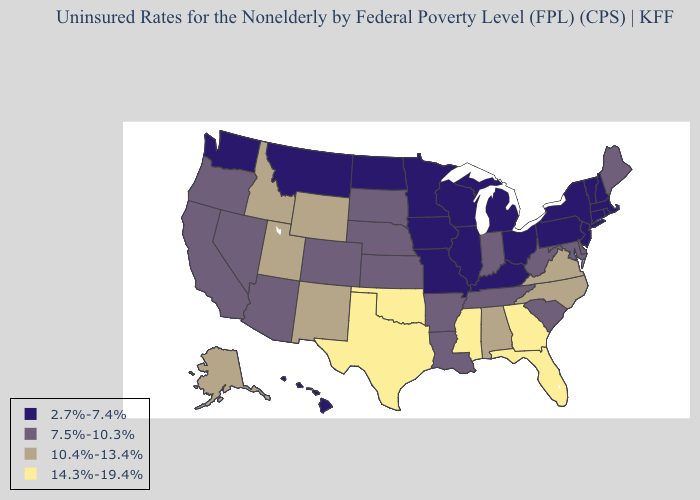Name the states that have a value in the range 10.4%-13.4%?
Keep it brief. Alabama, Alaska, Idaho, New Mexico, North Carolina, Utah, Virginia, Wyoming. What is the highest value in the West ?
Short answer required. 10.4%-13.4%. Which states have the lowest value in the USA?
Give a very brief answer. Connecticut, Hawaii, Illinois, Iowa, Kentucky, Massachusetts, Michigan, Minnesota, Missouri, Montana, New Hampshire, New Jersey, New York, North Dakota, Ohio, Pennsylvania, Rhode Island, Vermont, Washington, Wisconsin. Does Rhode Island have the lowest value in the Northeast?
Write a very short answer. Yes. Is the legend a continuous bar?
Concise answer only. No. Which states have the lowest value in the West?
Short answer required. Hawaii, Montana, Washington. Among the states that border Oregon , which have the highest value?
Give a very brief answer. Idaho. Does the first symbol in the legend represent the smallest category?
Quick response, please. Yes. What is the highest value in the USA?
Write a very short answer. 14.3%-19.4%. What is the highest value in the USA?
Answer briefly. 14.3%-19.4%. Name the states that have a value in the range 14.3%-19.4%?
Keep it brief. Florida, Georgia, Mississippi, Oklahoma, Texas. Name the states that have a value in the range 7.5%-10.3%?
Be succinct. Arizona, Arkansas, California, Colorado, Delaware, Indiana, Kansas, Louisiana, Maine, Maryland, Nebraska, Nevada, Oregon, South Carolina, South Dakota, Tennessee, West Virginia. Does the first symbol in the legend represent the smallest category?
Be succinct. Yes. What is the value of Georgia?
Concise answer only. 14.3%-19.4%. Among the states that border Alabama , which have the highest value?
Answer briefly. Florida, Georgia, Mississippi. 